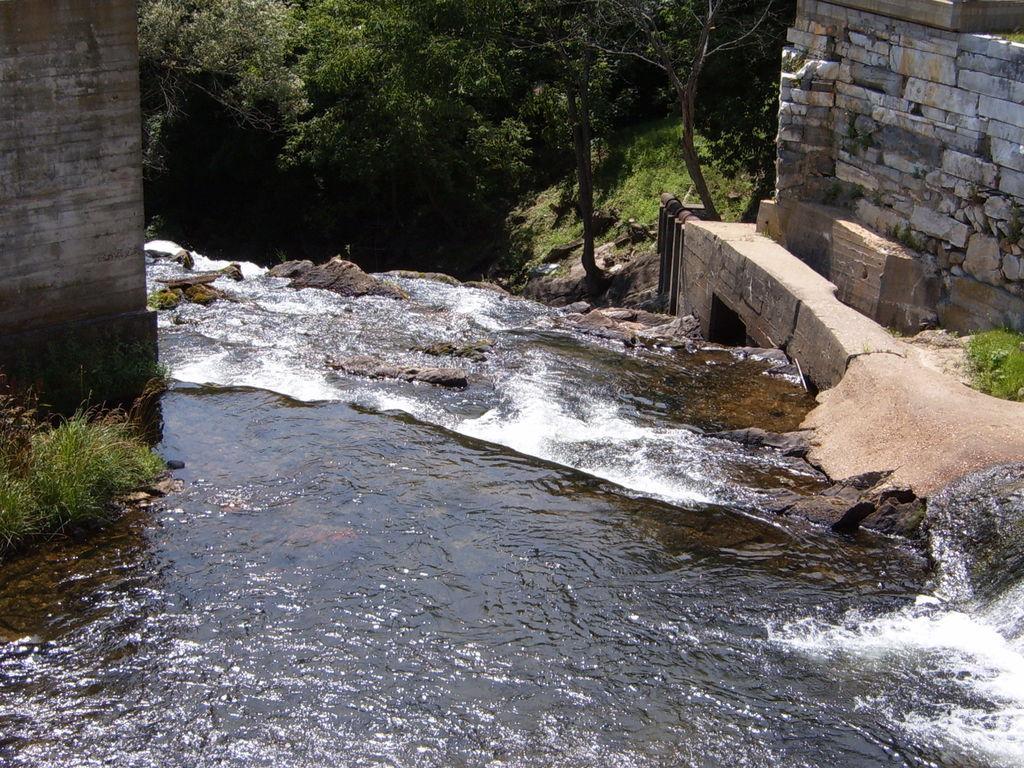Describe this image in one or two sentences. In this image I can see the water. In the background I can see few trees in green color and I can also see the wall. 